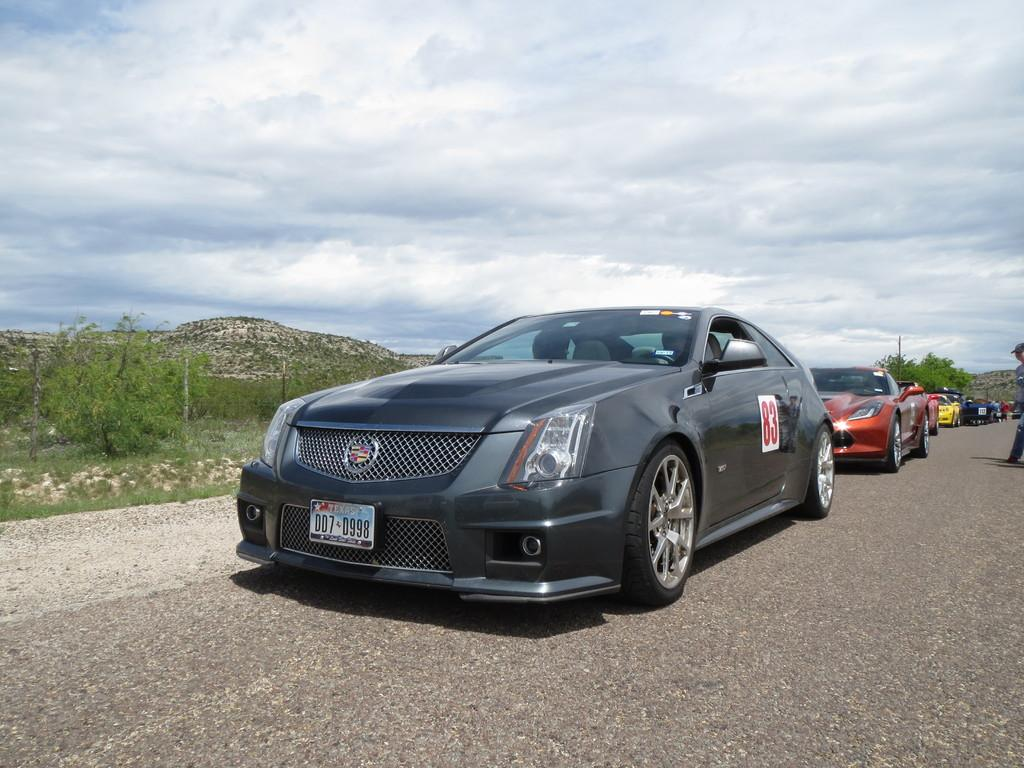What can be seen on the road in the image? There are vehicles on the road in the image. What type of natural elements are present in the image? There are trees and hills in the image. What is visible in the background of the image? The sky is visible in the background of the image. Can you see a cat playing with a string on one of the hills in the image? There is no cat or string present in the image; it features vehicles on the road, trees, hills, and the sky. 